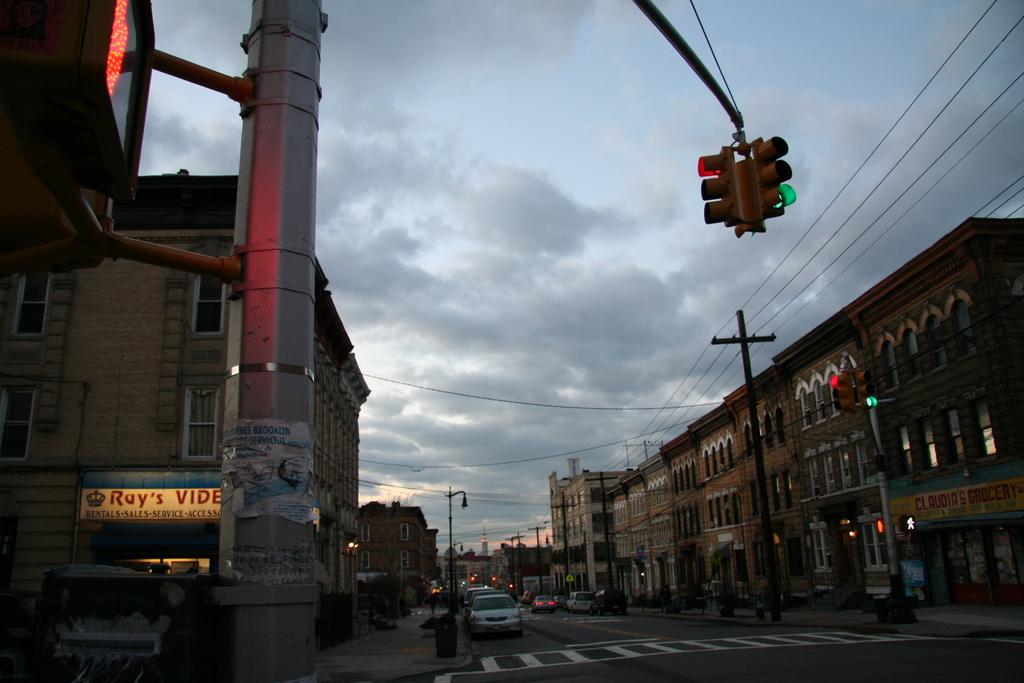What type of store is on the right under the yellow and green sign?
Offer a very short reply. Grocery. 